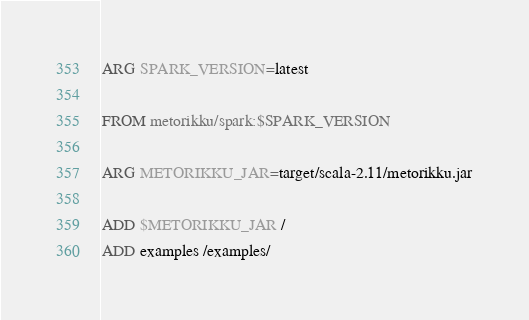<code> <loc_0><loc_0><loc_500><loc_500><_Dockerfile_>ARG SPARK_VERSION=latest

FROM metorikku/spark:$SPARK_VERSION

ARG METORIKKU_JAR=target/scala-2.11/metorikku.jar

ADD $METORIKKU_JAR /
ADD examples /examples/
</code> 